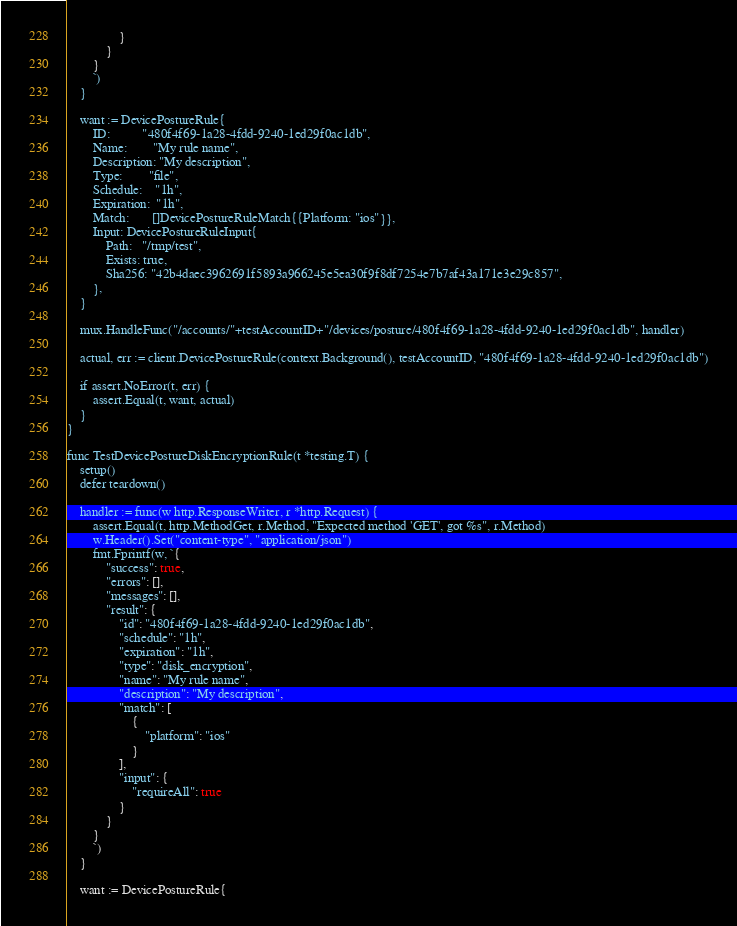Convert code to text. <code><loc_0><loc_0><loc_500><loc_500><_Go_>				}
			}
		}
		`)
	}

	want := DevicePostureRule{
		ID:          "480f4f69-1a28-4fdd-9240-1ed29f0ac1db",
		Name:        "My rule name",
		Description: "My description",
		Type:        "file",
		Schedule:    "1h",
		Expiration:  "1h",
		Match:       []DevicePostureRuleMatch{{Platform: "ios"}},
		Input: DevicePostureRuleInput{
			Path:   "/tmp/test",
			Exists: true,
			Sha256: "42b4daec3962691f5893a966245e5ea30f9f8df7254e7b7af43a171e3e29c857",
		},
	}

	mux.HandleFunc("/accounts/"+testAccountID+"/devices/posture/480f4f69-1a28-4fdd-9240-1ed29f0ac1db", handler)

	actual, err := client.DevicePostureRule(context.Background(), testAccountID, "480f4f69-1a28-4fdd-9240-1ed29f0ac1db")

	if assert.NoError(t, err) {
		assert.Equal(t, want, actual)
	}
}

func TestDevicePostureDiskEncryptionRule(t *testing.T) {
	setup()
	defer teardown()

	handler := func(w http.ResponseWriter, r *http.Request) {
		assert.Equal(t, http.MethodGet, r.Method, "Expected method 'GET', got %s", r.Method)
		w.Header().Set("content-type", "application/json")
		fmt.Fprintf(w, `{
			"success": true,
			"errors": [],
			"messages": [],
			"result": {
				"id": "480f4f69-1a28-4fdd-9240-1ed29f0ac1db",
				"schedule": "1h",
				"expiration": "1h",
				"type": "disk_encryption",
				"name": "My rule name",
				"description": "My description",
				"match": [
					{
						"platform": "ios"
					}
				],
				"input": {
					"requireAll": true
				}
			}
		}
		`)
	}

	want := DevicePostureRule{</code> 